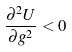Convert formula to latex. <formula><loc_0><loc_0><loc_500><loc_500>\frac { \partial ^ { 2 } U } { \partial g ^ { 2 } } < 0</formula> 